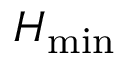Convert formula to latex. <formula><loc_0><loc_0><loc_500><loc_500>H _ { \min }</formula> 